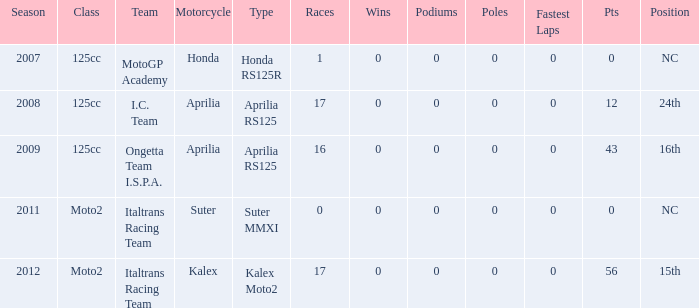How many pole positions were attained by the team in the season they had a kalex motorcycle? 0.0. 